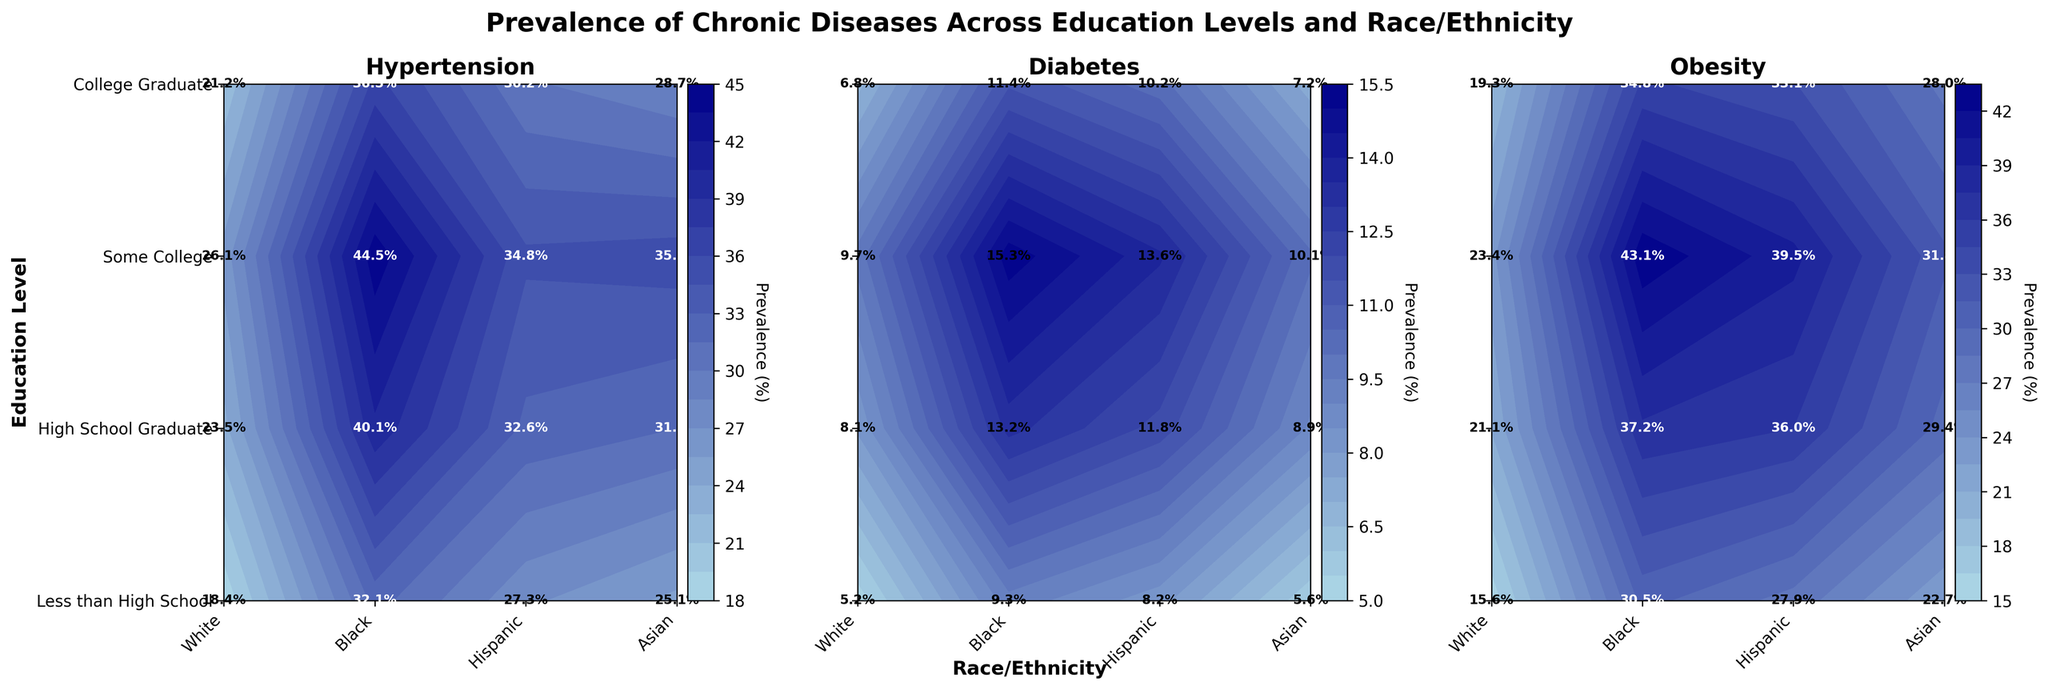What's the title of the figure? The title of the figure is located at the top and generally summarizes the content of the visualization. Here it is "Prevalence of Chronic Diseases Across Education Levels and Race/Ethnicity".
Answer: Prevalence of Chronic Diseases Across Education Levels and Race/Ethnicity Which disease has the highest prevalence among the Black population with less than a high school education? Look at the subplot for each disease and find the percentage for the Black population with less than a high school education. Hypertension has the highest percentage.
Answer: Hypertension What is the prevalence of diabetes among Asians with some college education? Look at the contour plot for diabetes and find the percentage for the Asian population with some college education.
Answer: 6.8% Which education level shows the lowest prevalence of obesity among Whites? Look at the obesity subplot and find the lowest percentage for Whites across different education levels. The lowest is for College Graduate.
Answer: College Graduate Compare the prevalence of hypertension between Whites and Blacks who are high school graduates. Look at the hypertension subplot and compare the percentages for Whites and Blacks who are high school graduates.
Answer: White: 31.5%, Black: 40.1% Among Hispanics with less than a high school education, which disease has the lowest prevalence? Look at the percentages for Hispanics with less than a high school education across all three diseases. Diabetes has the lowest prevalence.
Answer: Diabetes How does the prevalence of obesity change with increasing education levels among Asians? Track the percentage of obesity for Asians as you move from "Less than High School" to "College Graduate". The prevalence decreases from 23.4% to 15.6%.
Answer: Decreases What is the difference in the prevalence of diabetes between College Graduates and those with less than a high school education among Hispanics? Subtract the prevalence of diabetes for College Graduates from that for "Less than High School" among Hispanics (13.6% - 8.2%).
Answer: 4.1% In which racial/ethnic group and education level combination is the prevalence of obesity the highest? Find the highest percentage in the obesity subplot across all racial/ethnic groups and education levels. It is among Blacks with less than a high school education at 43.1%.
Answer: Blacks with less than a high school education What trend can be observed in the prevalence of hypertension among Whites as education levels increase? Analyze the percentages for hypertension among Whites from "Less than High School" to "College Graduate". The prevalence decreases from 35.2% to 25.1%.
Answer: Decreases 